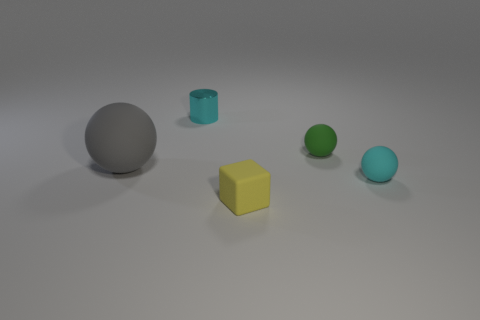Add 4 tiny brown rubber cylinders. How many objects exist? 9 Subtract all cylinders. How many objects are left? 4 Add 3 green shiny things. How many green shiny things exist? 3 Subtract 0 brown cubes. How many objects are left? 5 Subtract all big cyan rubber objects. Subtract all cyan metallic things. How many objects are left? 4 Add 1 gray rubber balls. How many gray rubber balls are left? 2 